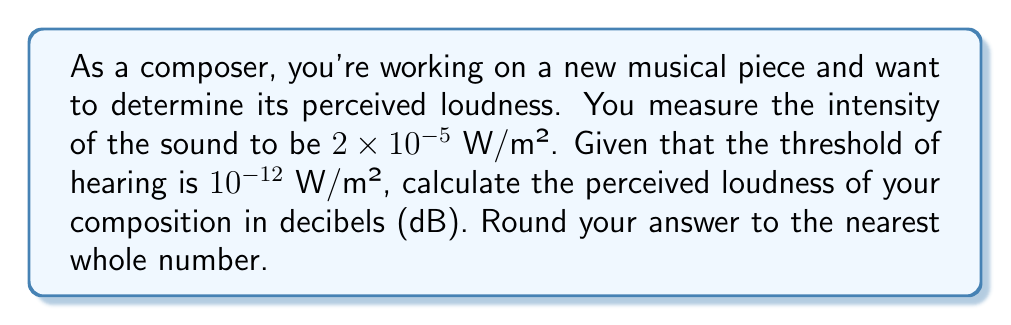Can you answer this question? To solve this problem, we'll use the decibel scale formula for sound intensity level:

$$\text{Sound Intensity Level (dB)} = 10 \log_{10}\left(\frac{I}{I_0}\right)$$

Where:
$I$ is the measured sound intensity
$I_0$ is the threshold of hearing (reference intensity)

Given:
$I = 2 \times 10^{-5}$ W/m²
$I_0 = 10^{-12}$ W/m²

Let's substitute these values into the formula:

$$\begin{align*}
\text{Sound Intensity Level} &= 10 \log_{10}\left(\frac{2 \times 10^{-5}}{10^{-12}}\right) \\[10pt]
&= 10 \log_{10}(2 \times 10^7) \\[10pt]
&= 10 \left(\log_{10}(2) + \log_{10}(10^7)\right) \\[10pt]
&= 10 (0.3010 + 7) \\[10pt]
&= 10 (7.3010) \\[10pt]
&= 73.01 \text{ dB}
\end{align*}$$

Rounding to the nearest whole number, we get 73 dB.
Answer: 73 dB 